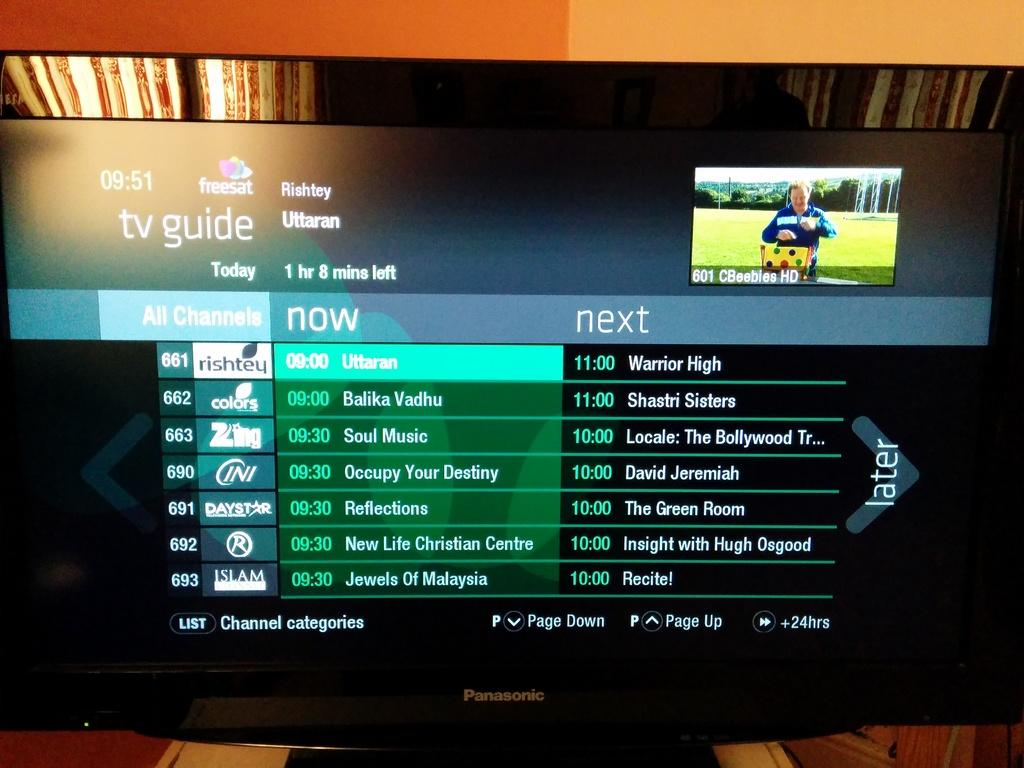<image>
Offer a succinct explanation of the picture presented. A TV guide diaplaying shows at 9, 9:30 and 11 